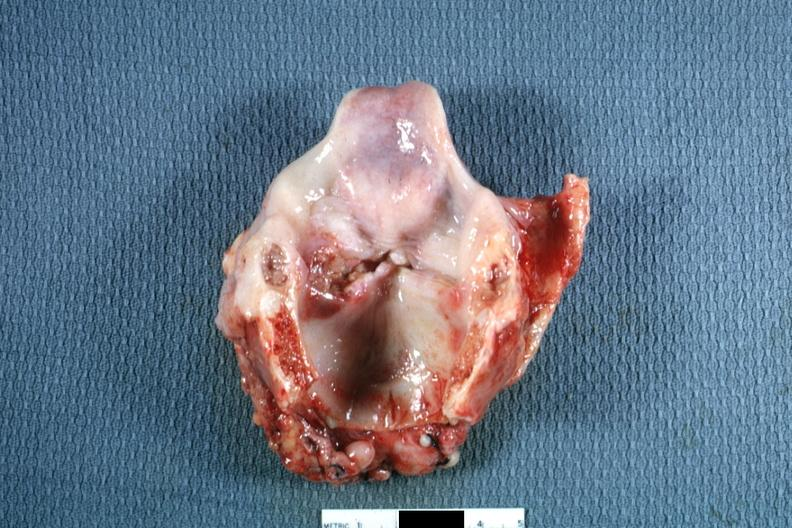does this image show ulcerative lesion left true cord quite good?
Answer the question using a single word or phrase. Yes 